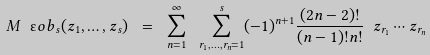<formula> <loc_0><loc_0><loc_500><loc_500>M \ " o b _ { s } ( z _ { 1 } , \dots , z _ { s } ) \ = \ \sum _ { n = 1 } ^ { \infty } \ \sum _ { r _ { 1 } , \dots , r _ { n } = 1 } ^ { s } ( - 1 ) ^ { n + 1 } \frac { ( 2 n - 2 ) ! } { ( n - 1 ) ! n ! } \ z _ { r _ { 1 } } \cdots z _ { r _ { n } }</formula> 